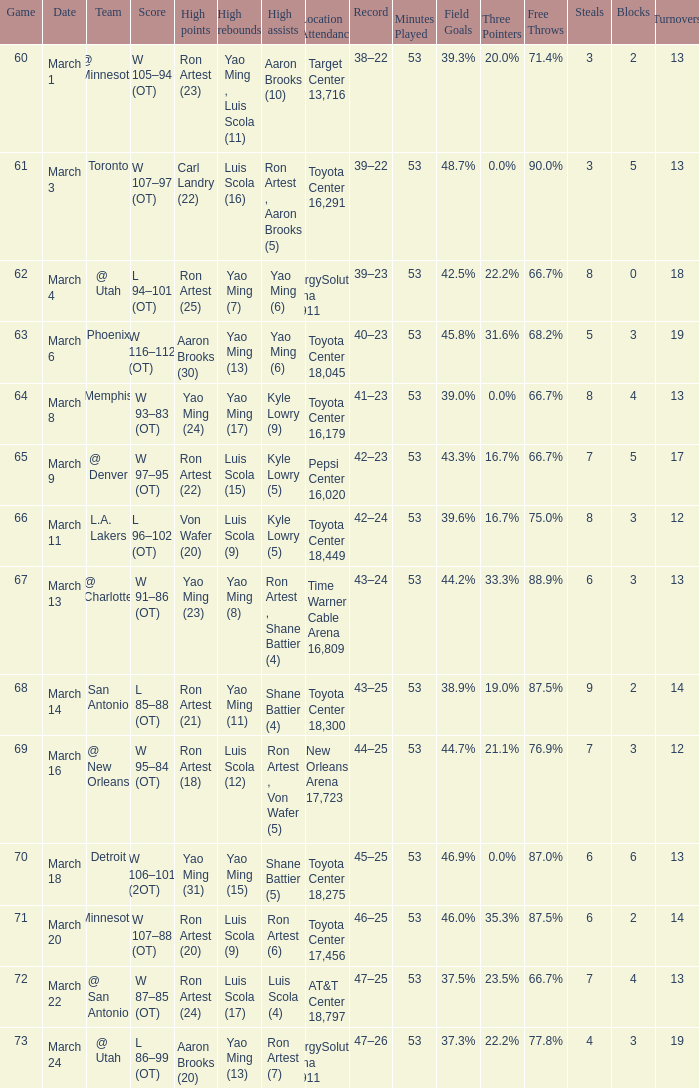On what date did the Rockets play Memphis? March 8. 